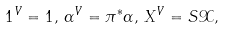Convert formula to latex. <formula><loc_0><loc_0><loc_500><loc_500>1 ^ { V } = 1 , \, \alpha ^ { V } = \pi ^ { * } \alpha , \, X ^ { V } = S \mathcal { X } ,</formula> 